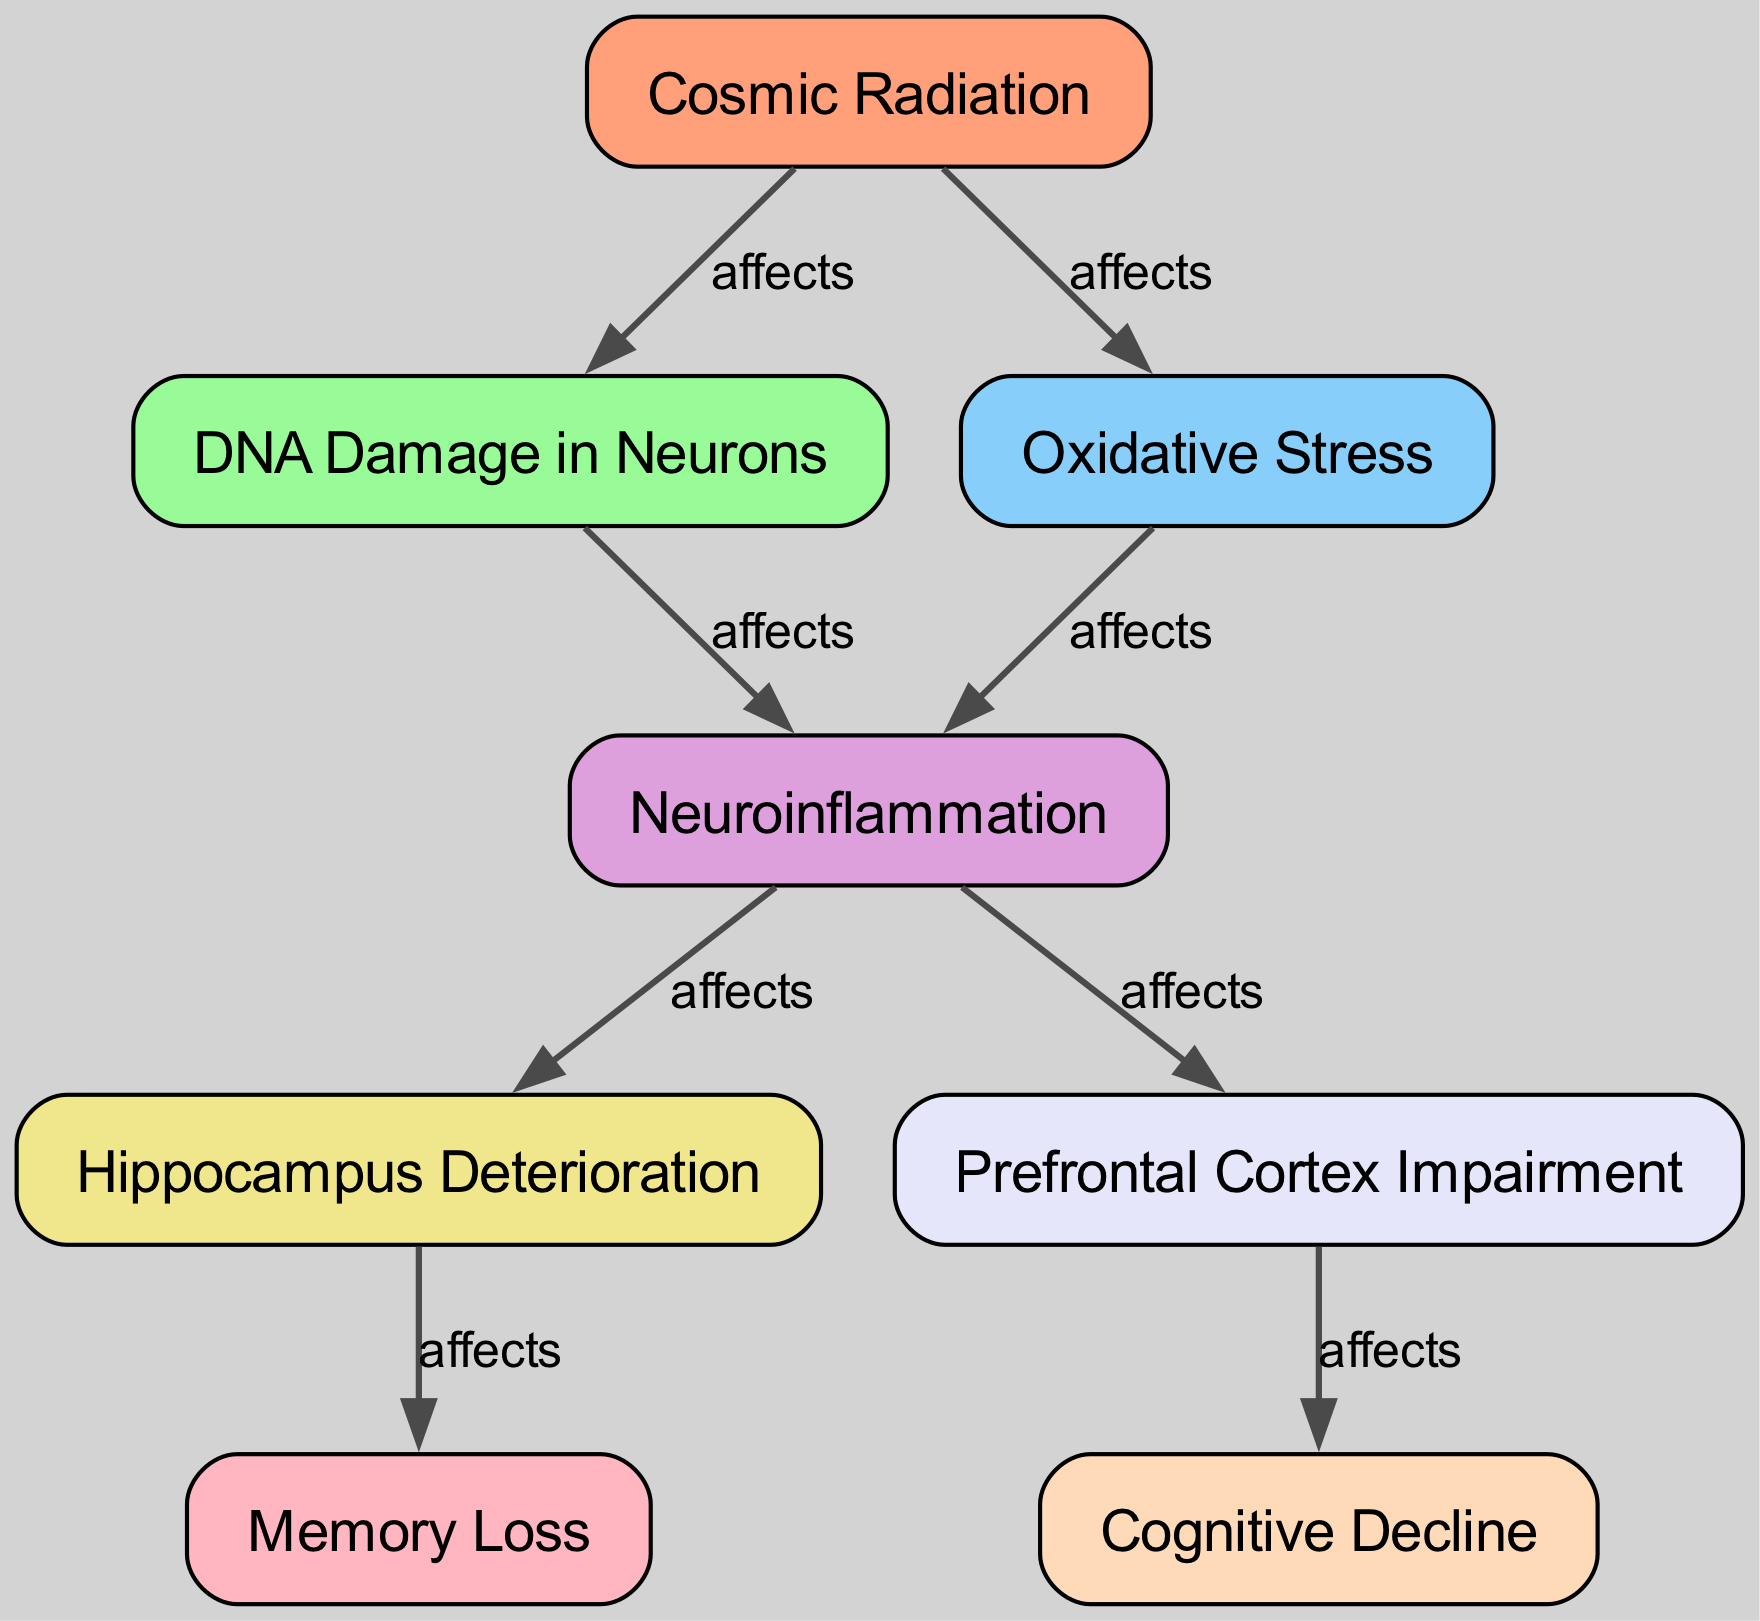What is the first element in the food chain? The first element is "Cosmic Radiation," which is the source of all subsequent effects in the diagram.
Answer: Cosmic Radiation How many total elements are in the diagram? There are 8 elements listed in the diagram, which can be counted directly from the provided data.
Answer: 8 Which two elements are affected directly by cosmic radiation? Cosmic radiation directly affects "DNA Damage in Neurons" and "Oxidative Stress," as indicated by the direct connections from cosmic radiation to these nodes.
Answer: DNA Damage in Neurons, Oxidative Stress What is the last element that is affected in the chain? The last element affected in the chain, based on the connections, is "Cognitive Decline." This highlights the final cognitive impact stemming from the preceding conditions.
Answer: Cognitive Decline Which element leads to memory loss? "Hippocampus Deterioration" leads to "Memory Loss," as denoted by the connection flowing from the hippocampus to memory loss.
Answer: Hippocampus Deterioration What element does oxidative stress connect to? "Oxidative Stress" connects to "Neuroinflammation," demonstrating a direct relationship between these two factors in the process.
Answer: Neuroinflammation How many edges are present in the diagram? The number of edges can be determined by counting the connections listed; there are 8 edges present in the food chain diagram.
Answer: 8 Describe the connection between "Neuroinflammation" and the cognitive functions. "Neuroinflammation" affects both the "Hippocampus" and "Prefrontal Cortex," which are critical regions for memory and executive function, respectively, thus impacting broader cognitive functions.
Answer: Hippocampus, Prefrontal Cortex What is the effect of multiple pathways leading from neuroinflammation? The multiple pathways illustrate how neuroinflammation can simultaneously impair both the hippocampus and the prefrontal cortex, affecting memory and higher cognitive processes, respectively.
Answer: Impaired memory and higher cognitive processes 